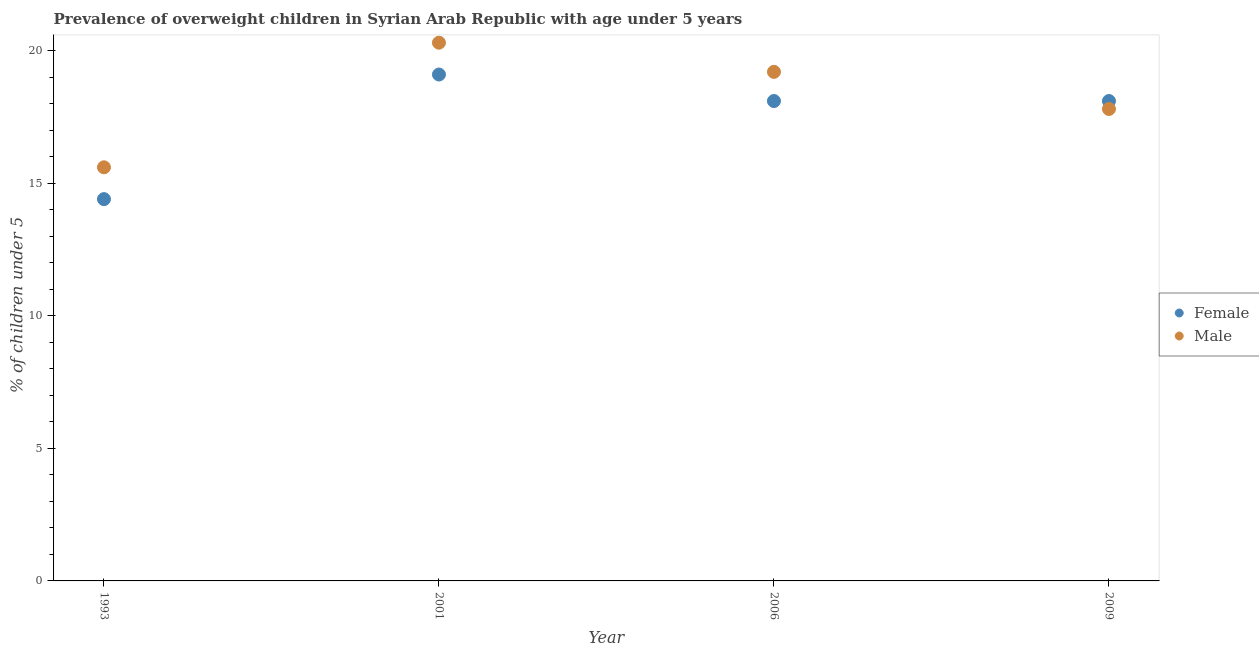How many different coloured dotlines are there?
Make the answer very short. 2. What is the percentage of obese female children in 2006?
Your answer should be compact. 18.1. Across all years, what is the maximum percentage of obese female children?
Ensure brevity in your answer.  19.1. Across all years, what is the minimum percentage of obese female children?
Your answer should be very brief. 14.4. In which year was the percentage of obese female children maximum?
Your response must be concise. 2001. In which year was the percentage of obese male children minimum?
Ensure brevity in your answer.  1993. What is the total percentage of obese female children in the graph?
Your response must be concise. 69.7. What is the difference between the percentage of obese male children in 1993 and that in 2001?
Offer a very short reply. -4.7. What is the difference between the percentage of obese female children in 2001 and the percentage of obese male children in 1993?
Offer a terse response. 3.5. What is the average percentage of obese female children per year?
Offer a very short reply. 17.43. In the year 2009, what is the difference between the percentage of obese female children and percentage of obese male children?
Your answer should be very brief. 0.3. In how many years, is the percentage of obese male children greater than 16 %?
Ensure brevity in your answer.  3. What is the ratio of the percentage of obese male children in 1993 to that in 2006?
Your response must be concise. 0.81. Is the percentage of obese male children in 1993 less than that in 2001?
Provide a succinct answer. Yes. Is the difference between the percentage of obese male children in 2006 and 2009 greater than the difference between the percentage of obese female children in 2006 and 2009?
Keep it short and to the point. Yes. What is the difference between the highest and the second highest percentage of obese male children?
Your answer should be very brief. 1.1. What is the difference between the highest and the lowest percentage of obese female children?
Give a very brief answer. 4.7. Does the percentage of obese female children monotonically increase over the years?
Give a very brief answer. No. How many dotlines are there?
Offer a terse response. 2. How many years are there in the graph?
Your response must be concise. 4. What is the difference between two consecutive major ticks on the Y-axis?
Provide a succinct answer. 5. Are the values on the major ticks of Y-axis written in scientific E-notation?
Offer a very short reply. No. Does the graph contain any zero values?
Make the answer very short. No. Does the graph contain grids?
Offer a terse response. No. Where does the legend appear in the graph?
Ensure brevity in your answer.  Center right. How many legend labels are there?
Give a very brief answer. 2. How are the legend labels stacked?
Provide a succinct answer. Vertical. What is the title of the graph?
Keep it short and to the point. Prevalence of overweight children in Syrian Arab Republic with age under 5 years. Does "Health Care" appear as one of the legend labels in the graph?
Keep it short and to the point. No. What is the label or title of the X-axis?
Provide a short and direct response. Year. What is the label or title of the Y-axis?
Your answer should be very brief.  % of children under 5. What is the  % of children under 5 of Female in 1993?
Your answer should be very brief. 14.4. What is the  % of children under 5 in Male in 1993?
Provide a short and direct response. 15.6. What is the  % of children under 5 of Female in 2001?
Make the answer very short. 19.1. What is the  % of children under 5 of Male in 2001?
Keep it short and to the point. 20.3. What is the  % of children under 5 of Female in 2006?
Provide a succinct answer. 18.1. What is the  % of children under 5 of Male in 2006?
Ensure brevity in your answer.  19.2. What is the  % of children under 5 of Female in 2009?
Offer a terse response. 18.1. What is the  % of children under 5 of Male in 2009?
Your answer should be compact. 17.8. Across all years, what is the maximum  % of children under 5 of Female?
Offer a very short reply. 19.1. Across all years, what is the maximum  % of children under 5 in Male?
Offer a very short reply. 20.3. Across all years, what is the minimum  % of children under 5 in Female?
Provide a succinct answer. 14.4. Across all years, what is the minimum  % of children under 5 of Male?
Your answer should be very brief. 15.6. What is the total  % of children under 5 in Female in the graph?
Your answer should be compact. 69.7. What is the total  % of children under 5 in Male in the graph?
Offer a very short reply. 72.9. What is the difference between the  % of children under 5 in Male in 1993 and that in 2001?
Offer a terse response. -4.7. What is the difference between the  % of children under 5 of Female in 1993 and that in 2009?
Your answer should be compact. -3.7. What is the difference between the  % of children under 5 in Male in 1993 and that in 2009?
Offer a very short reply. -2.2. What is the difference between the  % of children under 5 of Female in 2001 and that in 2006?
Make the answer very short. 1. What is the difference between the  % of children under 5 in Male in 2001 and that in 2006?
Keep it short and to the point. 1.1. What is the difference between the  % of children under 5 of Male in 2001 and that in 2009?
Ensure brevity in your answer.  2.5. What is the difference between the  % of children under 5 in Female in 2006 and that in 2009?
Your response must be concise. 0. What is the difference between the  % of children under 5 in Male in 2006 and that in 2009?
Give a very brief answer. 1.4. What is the difference between the  % of children under 5 of Female in 1993 and the  % of children under 5 of Male in 2006?
Make the answer very short. -4.8. What is the difference between the  % of children under 5 of Female in 2001 and the  % of children under 5 of Male in 2006?
Ensure brevity in your answer.  -0.1. What is the difference between the  % of children under 5 of Female in 2001 and the  % of children under 5 of Male in 2009?
Keep it short and to the point. 1.3. What is the average  % of children under 5 of Female per year?
Ensure brevity in your answer.  17.43. What is the average  % of children under 5 of Male per year?
Your response must be concise. 18.23. In the year 1993, what is the difference between the  % of children under 5 in Female and  % of children under 5 in Male?
Give a very brief answer. -1.2. In the year 2009, what is the difference between the  % of children under 5 of Female and  % of children under 5 of Male?
Ensure brevity in your answer.  0.3. What is the ratio of the  % of children under 5 in Female in 1993 to that in 2001?
Make the answer very short. 0.75. What is the ratio of the  % of children under 5 in Male in 1993 to that in 2001?
Make the answer very short. 0.77. What is the ratio of the  % of children under 5 in Female in 1993 to that in 2006?
Keep it short and to the point. 0.8. What is the ratio of the  % of children under 5 in Male in 1993 to that in 2006?
Keep it short and to the point. 0.81. What is the ratio of the  % of children under 5 of Female in 1993 to that in 2009?
Make the answer very short. 0.8. What is the ratio of the  % of children under 5 of Male in 1993 to that in 2009?
Provide a short and direct response. 0.88. What is the ratio of the  % of children under 5 of Female in 2001 to that in 2006?
Your response must be concise. 1.06. What is the ratio of the  % of children under 5 of Male in 2001 to that in 2006?
Ensure brevity in your answer.  1.06. What is the ratio of the  % of children under 5 of Female in 2001 to that in 2009?
Give a very brief answer. 1.06. What is the ratio of the  % of children under 5 in Male in 2001 to that in 2009?
Offer a terse response. 1.14. What is the ratio of the  % of children under 5 of Female in 2006 to that in 2009?
Ensure brevity in your answer.  1. What is the ratio of the  % of children under 5 of Male in 2006 to that in 2009?
Keep it short and to the point. 1.08. 